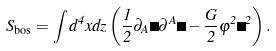Convert formula to latex. <formula><loc_0><loc_0><loc_500><loc_500>S _ { \text {bos} } = \int d ^ { 4 } x d z \left ( \frac { 1 } { 2 } \partial _ { A } \Phi \partial ^ { A } \Phi - \frac { G } { 2 } \varphi ^ { 2 } \Phi ^ { 2 } \right ) .</formula> 